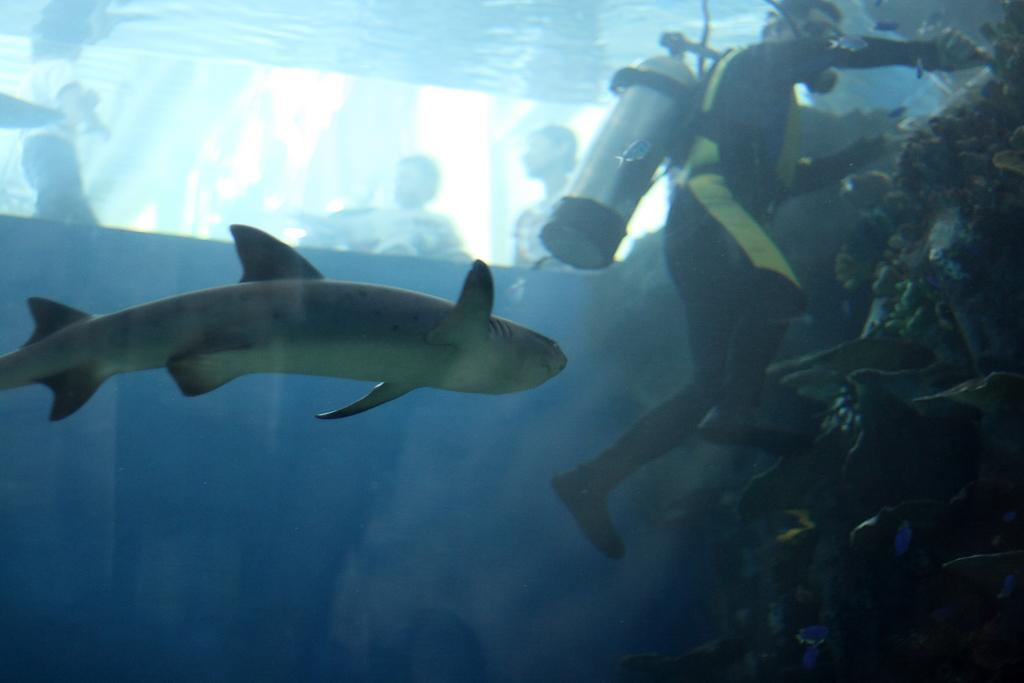What is in the water in the image? There is a shark in the water. What is the person in the water doing? The person is swimming in the water, wearing scuba diving dress and a cylinder. Are there any other people visible in the image? Yes, there are other persons visible in the image. What type of square object can be seen floating in the water? There is no square object visible in the image; it features a shark and a person swimming with scuba diving gear. 